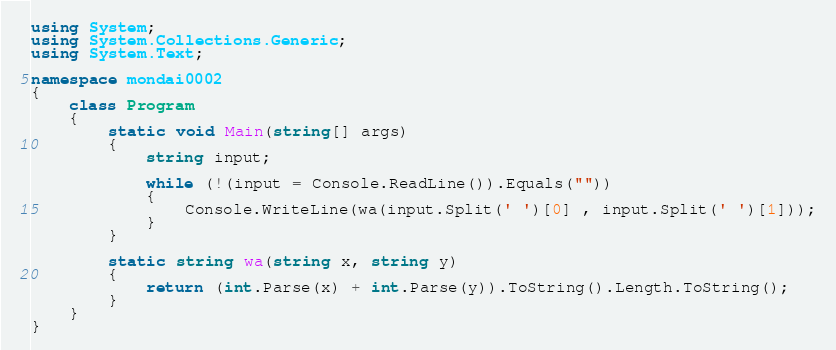Convert code to text. <code><loc_0><loc_0><loc_500><loc_500><_C#_>using System;
using System.Collections.Generic;
using System.Text;

namespace mondai0002
{
    class Program
    {
        static void Main(string[] args)
        {
            string input;

            while (!(input = Console.ReadLine()).Equals(""))
            {
                Console.WriteLine(wa(input.Split(' ')[0] , input.Split(' ')[1]));
            }
        }

        static string wa(string x, string y)
        {
            return (int.Parse(x) + int.Parse(y)).ToString().Length.ToString();
        }
    }
}</code> 